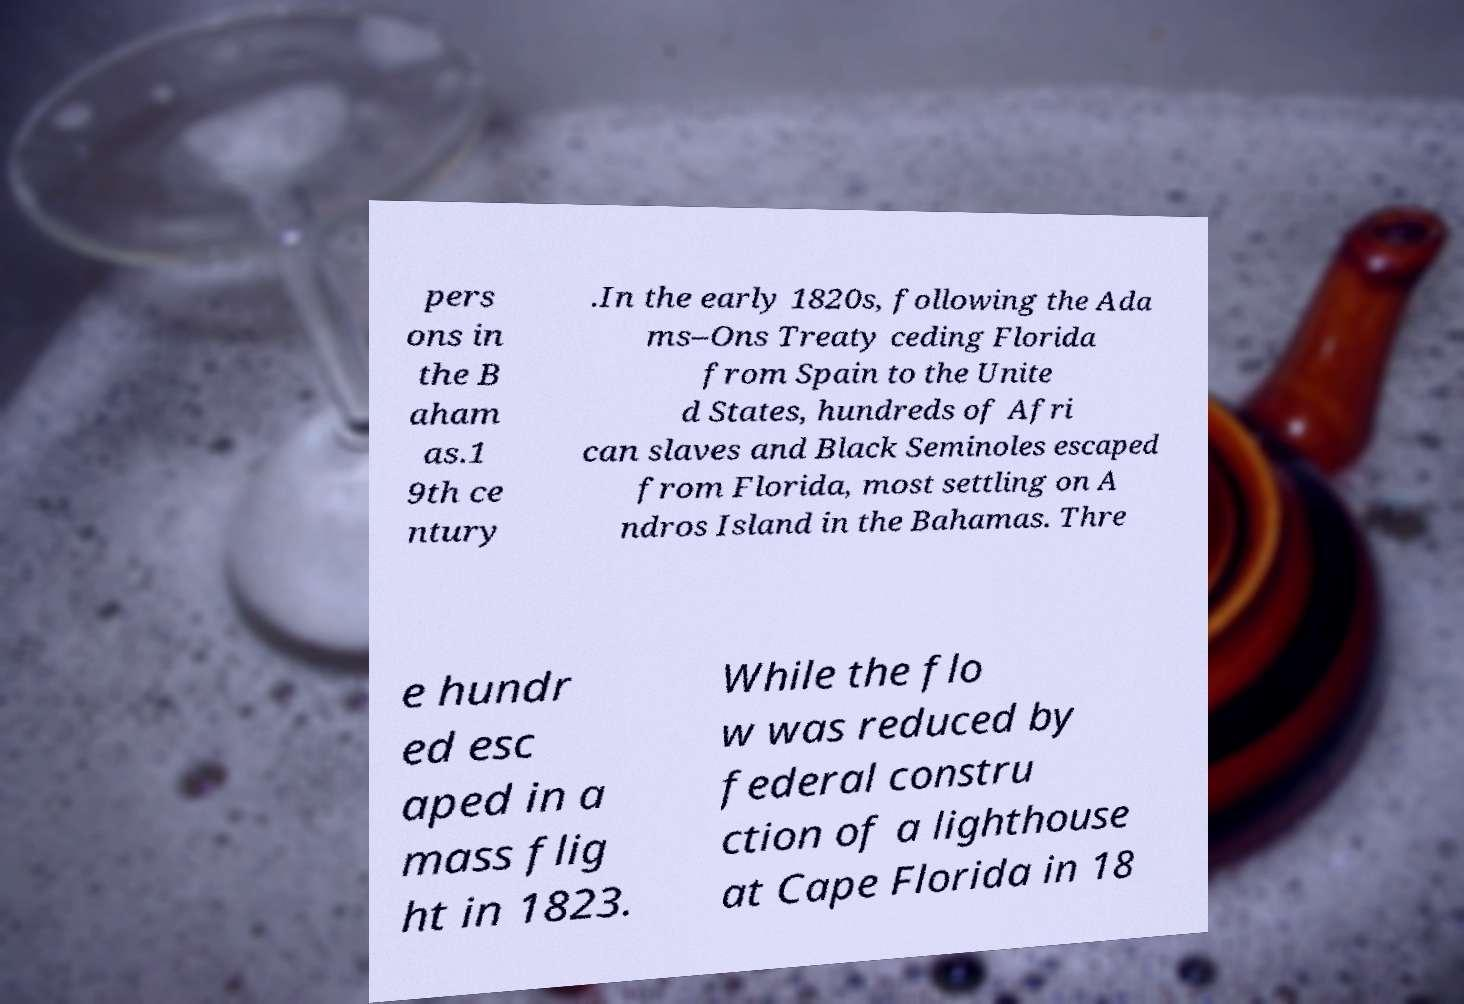What messages or text are displayed in this image? I need them in a readable, typed format. pers ons in the B aham as.1 9th ce ntury .In the early 1820s, following the Ada ms–Ons Treaty ceding Florida from Spain to the Unite d States, hundreds of Afri can slaves and Black Seminoles escaped from Florida, most settling on A ndros Island in the Bahamas. Thre e hundr ed esc aped in a mass flig ht in 1823. While the flo w was reduced by federal constru ction of a lighthouse at Cape Florida in 18 